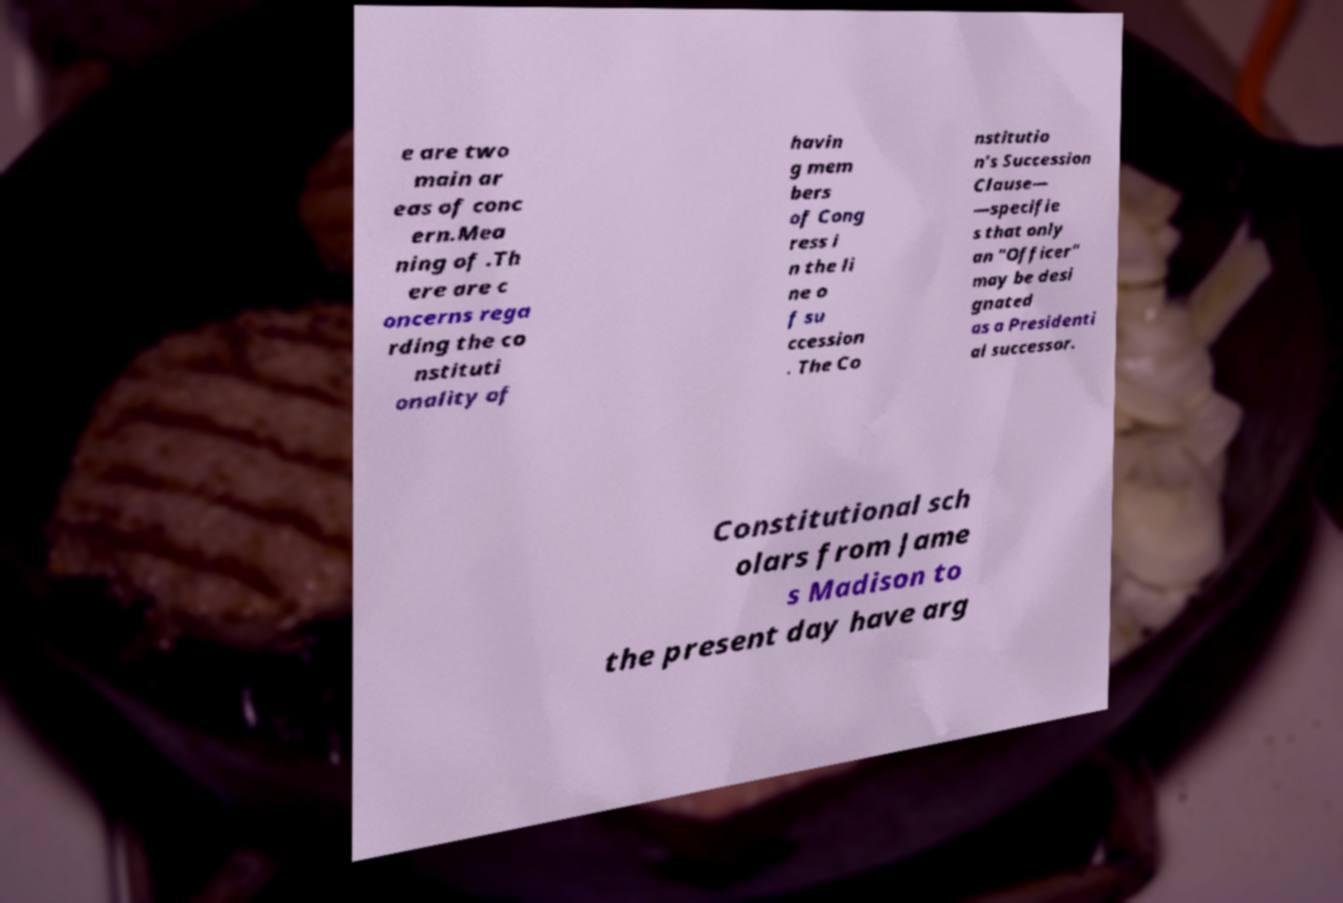Can you read and provide the text displayed in the image?This photo seems to have some interesting text. Can you extract and type it out for me? e are two main ar eas of conc ern.Mea ning of .Th ere are c oncerns rega rding the co nstituti onality of havin g mem bers of Cong ress i n the li ne o f su ccession . The Co nstitutio n's Succession Clause— —specifie s that only an "Officer" may be desi gnated as a Presidenti al successor. Constitutional sch olars from Jame s Madison to the present day have arg 